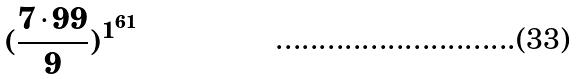<formula> <loc_0><loc_0><loc_500><loc_500>( \frac { 7 \cdot 9 9 } { 9 } ) ^ { 1 ^ { 6 1 } }</formula> 